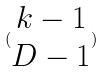<formula> <loc_0><loc_0><loc_500><loc_500>( \begin{matrix} k - 1 \\ D - 1 \end{matrix} )</formula> 